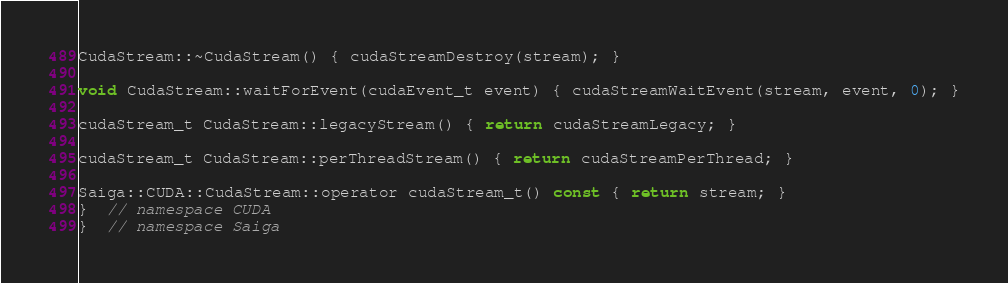<code> <loc_0><loc_0><loc_500><loc_500><_Cuda_>
CudaStream::~CudaStream() { cudaStreamDestroy(stream); }

void CudaStream::waitForEvent(cudaEvent_t event) { cudaStreamWaitEvent(stream, event, 0); }

cudaStream_t CudaStream::legacyStream() { return cudaStreamLegacy; }

cudaStream_t CudaStream::perThreadStream() { return cudaStreamPerThread; }

Saiga::CUDA::CudaStream::operator cudaStream_t() const { return stream; }
}  // namespace CUDA
}  // namespace Saiga
</code> 